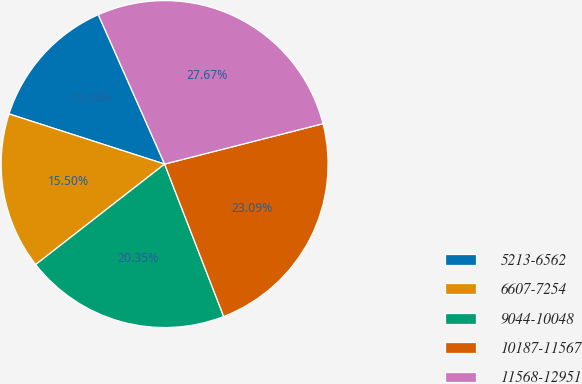Convert chart to OTSL. <chart><loc_0><loc_0><loc_500><loc_500><pie_chart><fcel>5213-6562<fcel>6607-7254<fcel>9044-10048<fcel>10187-11567<fcel>11568-12951<nl><fcel>13.39%<fcel>15.5%<fcel>20.35%<fcel>23.09%<fcel>27.67%<nl></chart> 